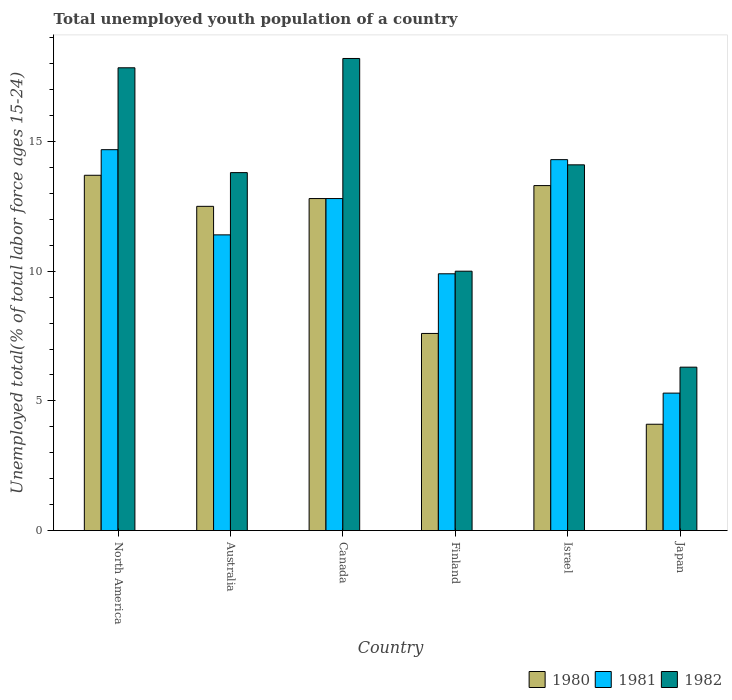How many groups of bars are there?
Provide a short and direct response. 6. Are the number of bars per tick equal to the number of legend labels?
Your answer should be very brief. Yes. Are the number of bars on each tick of the X-axis equal?
Ensure brevity in your answer.  Yes. How many bars are there on the 5th tick from the left?
Give a very brief answer. 3. How many bars are there on the 3rd tick from the right?
Provide a succinct answer. 3. What is the label of the 2nd group of bars from the left?
Provide a succinct answer. Australia. What is the percentage of total unemployed youth population of a country in 1982 in Finland?
Give a very brief answer. 10. Across all countries, what is the maximum percentage of total unemployed youth population of a country in 1980?
Ensure brevity in your answer.  13.7. Across all countries, what is the minimum percentage of total unemployed youth population of a country in 1982?
Provide a short and direct response. 6.3. What is the total percentage of total unemployed youth population of a country in 1981 in the graph?
Keep it short and to the point. 68.38. What is the difference between the percentage of total unemployed youth population of a country in 1982 in Australia and that in Japan?
Make the answer very short. 7.5. What is the difference between the percentage of total unemployed youth population of a country in 1980 in North America and the percentage of total unemployed youth population of a country in 1982 in Japan?
Your answer should be compact. 7.4. What is the average percentage of total unemployed youth population of a country in 1982 per country?
Offer a terse response. 13.37. What is the difference between the percentage of total unemployed youth population of a country of/in 1982 and percentage of total unemployed youth population of a country of/in 1981 in North America?
Keep it short and to the point. 3.16. What is the ratio of the percentage of total unemployed youth population of a country in 1982 in Canada to that in Japan?
Provide a succinct answer. 2.89. Is the percentage of total unemployed youth population of a country in 1981 in Japan less than that in North America?
Offer a terse response. Yes. Is the difference between the percentage of total unemployed youth population of a country in 1982 in Australia and Canada greater than the difference between the percentage of total unemployed youth population of a country in 1981 in Australia and Canada?
Offer a terse response. No. What is the difference between the highest and the second highest percentage of total unemployed youth population of a country in 1982?
Give a very brief answer. -0.36. What is the difference between the highest and the lowest percentage of total unemployed youth population of a country in 1980?
Ensure brevity in your answer.  9.6. In how many countries, is the percentage of total unemployed youth population of a country in 1982 greater than the average percentage of total unemployed youth population of a country in 1982 taken over all countries?
Provide a succinct answer. 4. Is the sum of the percentage of total unemployed youth population of a country in 1982 in Australia and North America greater than the maximum percentage of total unemployed youth population of a country in 1980 across all countries?
Your answer should be very brief. Yes. What does the 1st bar from the left in Australia represents?
Give a very brief answer. 1980. Is it the case that in every country, the sum of the percentage of total unemployed youth population of a country in 1982 and percentage of total unemployed youth population of a country in 1980 is greater than the percentage of total unemployed youth population of a country in 1981?
Your response must be concise. Yes. How many bars are there?
Provide a short and direct response. 18. Are all the bars in the graph horizontal?
Keep it short and to the point. No. How many countries are there in the graph?
Offer a terse response. 6. What is the difference between two consecutive major ticks on the Y-axis?
Provide a succinct answer. 5. Does the graph contain any zero values?
Your answer should be compact. No. How many legend labels are there?
Your answer should be very brief. 3. What is the title of the graph?
Your response must be concise. Total unemployed youth population of a country. Does "2010" appear as one of the legend labels in the graph?
Provide a succinct answer. No. What is the label or title of the Y-axis?
Offer a very short reply. Unemployed total(% of total labor force ages 15-24). What is the Unemployed total(% of total labor force ages 15-24) of 1980 in North America?
Ensure brevity in your answer.  13.7. What is the Unemployed total(% of total labor force ages 15-24) in 1981 in North America?
Provide a short and direct response. 14.68. What is the Unemployed total(% of total labor force ages 15-24) of 1982 in North America?
Make the answer very short. 17.84. What is the Unemployed total(% of total labor force ages 15-24) in 1981 in Australia?
Ensure brevity in your answer.  11.4. What is the Unemployed total(% of total labor force ages 15-24) in 1982 in Australia?
Keep it short and to the point. 13.8. What is the Unemployed total(% of total labor force ages 15-24) of 1980 in Canada?
Your answer should be very brief. 12.8. What is the Unemployed total(% of total labor force ages 15-24) of 1981 in Canada?
Your answer should be compact. 12.8. What is the Unemployed total(% of total labor force ages 15-24) in 1982 in Canada?
Provide a succinct answer. 18.2. What is the Unemployed total(% of total labor force ages 15-24) of 1980 in Finland?
Make the answer very short. 7.6. What is the Unemployed total(% of total labor force ages 15-24) of 1981 in Finland?
Offer a terse response. 9.9. What is the Unemployed total(% of total labor force ages 15-24) in 1982 in Finland?
Provide a short and direct response. 10. What is the Unemployed total(% of total labor force ages 15-24) of 1980 in Israel?
Make the answer very short. 13.3. What is the Unemployed total(% of total labor force ages 15-24) in 1981 in Israel?
Your answer should be very brief. 14.3. What is the Unemployed total(% of total labor force ages 15-24) of 1982 in Israel?
Offer a terse response. 14.1. What is the Unemployed total(% of total labor force ages 15-24) in 1980 in Japan?
Your response must be concise. 4.1. What is the Unemployed total(% of total labor force ages 15-24) in 1981 in Japan?
Offer a terse response. 5.3. What is the Unemployed total(% of total labor force ages 15-24) in 1982 in Japan?
Your response must be concise. 6.3. Across all countries, what is the maximum Unemployed total(% of total labor force ages 15-24) in 1980?
Ensure brevity in your answer.  13.7. Across all countries, what is the maximum Unemployed total(% of total labor force ages 15-24) in 1981?
Your answer should be very brief. 14.68. Across all countries, what is the maximum Unemployed total(% of total labor force ages 15-24) of 1982?
Ensure brevity in your answer.  18.2. Across all countries, what is the minimum Unemployed total(% of total labor force ages 15-24) in 1980?
Give a very brief answer. 4.1. Across all countries, what is the minimum Unemployed total(% of total labor force ages 15-24) of 1981?
Your response must be concise. 5.3. Across all countries, what is the minimum Unemployed total(% of total labor force ages 15-24) in 1982?
Provide a succinct answer. 6.3. What is the total Unemployed total(% of total labor force ages 15-24) of 1980 in the graph?
Give a very brief answer. 64. What is the total Unemployed total(% of total labor force ages 15-24) of 1981 in the graph?
Offer a very short reply. 68.38. What is the total Unemployed total(% of total labor force ages 15-24) in 1982 in the graph?
Your answer should be compact. 80.24. What is the difference between the Unemployed total(% of total labor force ages 15-24) in 1980 in North America and that in Australia?
Offer a terse response. 1.2. What is the difference between the Unemployed total(% of total labor force ages 15-24) of 1981 in North America and that in Australia?
Provide a short and direct response. 3.28. What is the difference between the Unemployed total(% of total labor force ages 15-24) in 1982 in North America and that in Australia?
Your answer should be compact. 4.04. What is the difference between the Unemployed total(% of total labor force ages 15-24) in 1980 in North America and that in Canada?
Offer a terse response. 0.9. What is the difference between the Unemployed total(% of total labor force ages 15-24) in 1981 in North America and that in Canada?
Offer a very short reply. 1.88. What is the difference between the Unemployed total(% of total labor force ages 15-24) of 1982 in North America and that in Canada?
Your answer should be compact. -0.36. What is the difference between the Unemployed total(% of total labor force ages 15-24) in 1980 in North America and that in Finland?
Keep it short and to the point. 6.1. What is the difference between the Unemployed total(% of total labor force ages 15-24) in 1981 in North America and that in Finland?
Your response must be concise. 4.78. What is the difference between the Unemployed total(% of total labor force ages 15-24) of 1982 in North America and that in Finland?
Offer a terse response. 7.84. What is the difference between the Unemployed total(% of total labor force ages 15-24) in 1980 in North America and that in Israel?
Your answer should be very brief. 0.4. What is the difference between the Unemployed total(% of total labor force ages 15-24) of 1981 in North America and that in Israel?
Provide a succinct answer. 0.38. What is the difference between the Unemployed total(% of total labor force ages 15-24) in 1982 in North America and that in Israel?
Provide a succinct answer. 3.74. What is the difference between the Unemployed total(% of total labor force ages 15-24) in 1980 in North America and that in Japan?
Make the answer very short. 9.6. What is the difference between the Unemployed total(% of total labor force ages 15-24) of 1981 in North America and that in Japan?
Keep it short and to the point. 9.38. What is the difference between the Unemployed total(% of total labor force ages 15-24) of 1982 in North America and that in Japan?
Make the answer very short. 11.54. What is the difference between the Unemployed total(% of total labor force ages 15-24) in 1980 in Australia and that in Canada?
Your answer should be compact. -0.3. What is the difference between the Unemployed total(% of total labor force ages 15-24) of 1981 in Australia and that in Canada?
Offer a terse response. -1.4. What is the difference between the Unemployed total(% of total labor force ages 15-24) of 1982 in Australia and that in Canada?
Provide a succinct answer. -4.4. What is the difference between the Unemployed total(% of total labor force ages 15-24) of 1981 in Australia and that in Finland?
Your answer should be very brief. 1.5. What is the difference between the Unemployed total(% of total labor force ages 15-24) of 1982 in Australia and that in Finland?
Your answer should be compact. 3.8. What is the difference between the Unemployed total(% of total labor force ages 15-24) of 1982 in Australia and that in Japan?
Your response must be concise. 7.5. What is the difference between the Unemployed total(% of total labor force ages 15-24) in 1980 in Canada and that in Israel?
Your response must be concise. -0.5. What is the difference between the Unemployed total(% of total labor force ages 15-24) in 1981 in Canada and that in Israel?
Keep it short and to the point. -1.5. What is the difference between the Unemployed total(% of total labor force ages 15-24) in 1982 in Canada and that in Japan?
Provide a short and direct response. 11.9. What is the difference between the Unemployed total(% of total labor force ages 15-24) in 1980 in Finland and that in Israel?
Make the answer very short. -5.7. What is the difference between the Unemployed total(% of total labor force ages 15-24) in 1981 in Finland and that in Israel?
Offer a very short reply. -4.4. What is the difference between the Unemployed total(% of total labor force ages 15-24) in 1980 in Finland and that in Japan?
Give a very brief answer. 3.5. What is the difference between the Unemployed total(% of total labor force ages 15-24) in 1981 in Finland and that in Japan?
Ensure brevity in your answer.  4.6. What is the difference between the Unemployed total(% of total labor force ages 15-24) in 1981 in Israel and that in Japan?
Ensure brevity in your answer.  9. What is the difference between the Unemployed total(% of total labor force ages 15-24) of 1982 in Israel and that in Japan?
Your response must be concise. 7.8. What is the difference between the Unemployed total(% of total labor force ages 15-24) of 1980 in North America and the Unemployed total(% of total labor force ages 15-24) of 1981 in Australia?
Ensure brevity in your answer.  2.3. What is the difference between the Unemployed total(% of total labor force ages 15-24) in 1980 in North America and the Unemployed total(% of total labor force ages 15-24) in 1982 in Australia?
Offer a terse response. -0.1. What is the difference between the Unemployed total(% of total labor force ages 15-24) in 1981 in North America and the Unemployed total(% of total labor force ages 15-24) in 1982 in Australia?
Ensure brevity in your answer.  0.88. What is the difference between the Unemployed total(% of total labor force ages 15-24) of 1980 in North America and the Unemployed total(% of total labor force ages 15-24) of 1981 in Canada?
Offer a very short reply. 0.9. What is the difference between the Unemployed total(% of total labor force ages 15-24) of 1980 in North America and the Unemployed total(% of total labor force ages 15-24) of 1982 in Canada?
Your response must be concise. -4.5. What is the difference between the Unemployed total(% of total labor force ages 15-24) in 1981 in North America and the Unemployed total(% of total labor force ages 15-24) in 1982 in Canada?
Make the answer very short. -3.52. What is the difference between the Unemployed total(% of total labor force ages 15-24) in 1980 in North America and the Unemployed total(% of total labor force ages 15-24) in 1981 in Finland?
Ensure brevity in your answer.  3.8. What is the difference between the Unemployed total(% of total labor force ages 15-24) in 1980 in North America and the Unemployed total(% of total labor force ages 15-24) in 1982 in Finland?
Your answer should be compact. 3.7. What is the difference between the Unemployed total(% of total labor force ages 15-24) in 1981 in North America and the Unemployed total(% of total labor force ages 15-24) in 1982 in Finland?
Provide a succinct answer. 4.68. What is the difference between the Unemployed total(% of total labor force ages 15-24) of 1980 in North America and the Unemployed total(% of total labor force ages 15-24) of 1981 in Israel?
Offer a terse response. -0.6. What is the difference between the Unemployed total(% of total labor force ages 15-24) of 1980 in North America and the Unemployed total(% of total labor force ages 15-24) of 1982 in Israel?
Ensure brevity in your answer.  -0.4. What is the difference between the Unemployed total(% of total labor force ages 15-24) in 1981 in North America and the Unemployed total(% of total labor force ages 15-24) in 1982 in Israel?
Ensure brevity in your answer.  0.58. What is the difference between the Unemployed total(% of total labor force ages 15-24) of 1980 in North America and the Unemployed total(% of total labor force ages 15-24) of 1981 in Japan?
Ensure brevity in your answer.  8.4. What is the difference between the Unemployed total(% of total labor force ages 15-24) in 1980 in North America and the Unemployed total(% of total labor force ages 15-24) in 1982 in Japan?
Make the answer very short. 7.4. What is the difference between the Unemployed total(% of total labor force ages 15-24) of 1981 in North America and the Unemployed total(% of total labor force ages 15-24) of 1982 in Japan?
Ensure brevity in your answer.  8.38. What is the difference between the Unemployed total(% of total labor force ages 15-24) in 1980 in Australia and the Unemployed total(% of total labor force ages 15-24) in 1981 in Canada?
Your answer should be compact. -0.3. What is the difference between the Unemployed total(% of total labor force ages 15-24) of 1980 in Australia and the Unemployed total(% of total labor force ages 15-24) of 1981 in Finland?
Provide a short and direct response. 2.6. What is the difference between the Unemployed total(% of total labor force ages 15-24) in 1980 in Australia and the Unemployed total(% of total labor force ages 15-24) in 1981 in Israel?
Make the answer very short. -1.8. What is the difference between the Unemployed total(% of total labor force ages 15-24) of 1980 in Australia and the Unemployed total(% of total labor force ages 15-24) of 1981 in Japan?
Keep it short and to the point. 7.2. What is the difference between the Unemployed total(% of total labor force ages 15-24) of 1980 in Australia and the Unemployed total(% of total labor force ages 15-24) of 1982 in Japan?
Offer a terse response. 6.2. What is the difference between the Unemployed total(% of total labor force ages 15-24) in 1980 in Canada and the Unemployed total(% of total labor force ages 15-24) in 1981 in Finland?
Ensure brevity in your answer.  2.9. What is the difference between the Unemployed total(% of total labor force ages 15-24) of 1981 in Canada and the Unemployed total(% of total labor force ages 15-24) of 1982 in Finland?
Offer a terse response. 2.8. What is the difference between the Unemployed total(% of total labor force ages 15-24) of 1980 in Canada and the Unemployed total(% of total labor force ages 15-24) of 1981 in Israel?
Keep it short and to the point. -1.5. What is the difference between the Unemployed total(% of total labor force ages 15-24) in 1980 in Canada and the Unemployed total(% of total labor force ages 15-24) in 1982 in Israel?
Provide a succinct answer. -1.3. What is the difference between the Unemployed total(% of total labor force ages 15-24) in 1980 in Canada and the Unemployed total(% of total labor force ages 15-24) in 1981 in Japan?
Your response must be concise. 7.5. What is the difference between the Unemployed total(% of total labor force ages 15-24) of 1981 in Canada and the Unemployed total(% of total labor force ages 15-24) of 1982 in Japan?
Keep it short and to the point. 6.5. What is the difference between the Unemployed total(% of total labor force ages 15-24) of 1980 in Finland and the Unemployed total(% of total labor force ages 15-24) of 1981 in Israel?
Provide a short and direct response. -6.7. What is the difference between the Unemployed total(% of total labor force ages 15-24) in 1980 in Finland and the Unemployed total(% of total labor force ages 15-24) in 1982 in Israel?
Offer a very short reply. -6.5. What is the difference between the Unemployed total(% of total labor force ages 15-24) in 1981 in Finland and the Unemployed total(% of total labor force ages 15-24) in 1982 in Israel?
Make the answer very short. -4.2. What is the difference between the Unemployed total(% of total labor force ages 15-24) of 1980 in Finland and the Unemployed total(% of total labor force ages 15-24) of 1981 in Japan?
Your answer should be very brief. 2.3. What is the difference between the Unemployed total(% of total labor force ages 15-24) of 1980 in Finland and the Unemployed total(% of total labor force ages 15-24) of 1982 in Japan?
Offer a terse response. 1.3. What is the difference between the Unemployed total(% of total labor force ages 15-24) in 1980 in Israel and the Unemployed total(% of total labor force ages 15-24) in 1982 in Japan?
Your answer should be compact. 7. What is the average Unemployed total(% of total labor force ages 15-24) of 1980 per country?
Make the answer very short. 10.67. What is the average Unemployed total(% of total labor force ages 15-24) in 1981 per country?
Make the answer very short. 11.4. What is the average Unemployed total(% of total labor force ages 15-24) of 1982 per country?
Make the answer very short. 13.37. What is the difference between the Unemployed total(% of total labor force ages 15-24) in 1980 and Unemployed total(% of total labor force ages 15-24) in 1981 in North America?
Keep it short and to the point. -0.99. What is the difference between the Unemployed total(% of total labor force ages 15-24) of 1980 and Unemployed total(% of total labor force ages 15-24) of 1982 in North America?
Give a very brief answer. -4.14. What is the difference between the Unemployed total(% of total labor force ages 15-24) in 1981 and Unemployed total(% of total labor force ages 15-24) in 1982 in North America?
Keep it short and to the point. -3.16. What is the difference between the Unemployed total(% of total labor force ages 15-24) of 1981 and Unemployed total(% of total labor force ages 15-24) of 1982 in Australia?
Ensure brevity in your answer.  -2.4. What is the difference between the Unemployed total(% of total labor force ages 15-24) in 1980 and Unemployed total(% of total labor force ages 15-24) in 1981 in Canada?
Your response must be concise. 0. What is the difference between the Unemployed total(% of total labor force ages 15-24) of 1981 and Unemployed total(% of total labor force ages 15-24) of 1982 in Finland?
Ensure brevity in your answer.  -0.1. What is the difference between the Unemployed total(% of total labor force ages 15-24) of 1980 and Unemployed total(% of total labor force ages 15-24) of 1981 in Israel?
Give a very brief answer. -1. What is the difference between the Unemployed total(% of total labor force ages 15-24) in 1980 and Unemployed total(% of total labor force ages 15-24) in 1982 in Israel?
Your answer should be very brief. -0.8. What is the difference between the Unemployed total(% of total labor force ages 15-24) in 1981 and Unemployed total(% of total labor force ages 15-24) in 1982 in Israel?
Make the answer very short. 0.2. What is the difference between the Unemployed total(% of total labor force ages 15-24) of 1980 and Unemployed total(% of total labor force ages 15-24) of 1982 in Japan?
Your answer should be compact. -2.2. What is the ratio of the Unemployed total(% of total labor force ages 15-24) in 1980 in North America to that in Australia?
Keep it short and to the point. 1.1. What is the ratio of the Unemployed total(% of total labor force ages 15-24) in 1981 in North America to that in Australia?
Offer a very short reply. 1.29. What is the ratio of the Unemployed total(% of total labor force ages 15-24) in 1982 in North America to that in Australia?
Provide a short and direct response. 1.29. What is the ratio of the Unemployed total(% of total labor force ages 15-24) of 1980 in North America to that in Canada?
Keep it short and to the point. 1.07. What is the ratio of the Unemployed total(% of total labor force ages 15-24) of 1981 in North America to that in Canada?
Make the answer very short. 1.15. What is the ratio of the Unemployed total(% of total labor force ages 15-24) in 1982 in North America to that in Canada?
Your response must be concise. 0.98. What is the ratio of the Unemployed total(% of total labor force ages 15-24) of 1980 in North America to that in Finland?
Your answer should be very brief. 1.8. What is the ratio of the Unemployed total(% of total labor force ages 15-24) in 1981 in North America to that in Finland?
Your answer should be compact. 1.48. What is the ratio of the Unemployed total(% of total labor force ages 15-24) of 1982 in North America to that in Finland?
Provide a short and direct response. 1.78. What is the ratio of the Unemployed total(% of total labor force ages 15-24) in 1980 in North America to that in Israel?
Make the answer very short. 1.03. What is the ratio of the Unemployed total(% of total labor force ages 15-24) in 1981 in North America to that in Israel?
Your answer should be very brief. 1.03. What is the ratio of the Unemployed total(% of total labor force ages 15-24) of 1982 in North America to that in Israel?
Give a very brief answer. 1.27. What is the ratio of the Unemployed total(% of total labor force ages 15-24) in 1980 in North America to that in Japan?
Your answer should be compact. 3.34. What is the ratio of the Unemployed total(% of total labor force ages 15-24) of 1981 in North America to that in Japan?
Your answer should be compact. 2.77. What is the ratio of the Unemployed total(% of total labor force ages 15-24) of 1982 in North America to that in Japan?
Provide a succinct answer. 2.83. What is the ratio of the Unemployed total(% of total labor force ages 15-24) of 1980 in Australia to that in Canada?
Offer a very short reply. 0.98. What is the ratio of the Unemployed total(% of total labor force ages 15-24) in 1981 in Australia to that in Canada?
Ensure brevity in your answer.  0.89. What is the ratio of the Unemployed total(% of total labor force ages 15-24) of 1982 in Australia to that in Canada?
Provide a short and direct response. 0.76. What is the ratio of the Unemployed total(% of total labor force ages 15-24) in 1980 in Australia to that in Finland?
Offer a terse response. 1.64. What is the ratio of the Unemployed total(% of total labor force ages 15-24) in 1981 in Australia to that in Finland?
Give a very brief answer. 1.15. What is the ratio of the Unemployed total(% of total labor force ages 15-24) in 1982 in Australia to that in Finland?
Offer a very short reply. 1.38. What is the ratio of the Unemployed total(% of total labor force ages 15-24) in 1980 in Australia to that in Israel?
Your answer should be compact. 0.94. What is the ratio of the Unemployed total(% of total labor force ages 15-24) in 1981 in Australia to that in Israel?
Provide a succinct answer. 0.8. What is the ratio of the Unemployed total(% of total labor force ages 15-24) of 1982 in Australia to that in Israel?
Make the answer very short. 0.98. What is the ratio of the Unemployed total(% of total labor force ages 15-24) in 1980 in Australia to that in Japan?
Your response must be concise. 3.05. What is the ratio of the Unemployed total(% of total labor force ages 15-24) of 1981 in Australia to that in Japan?
Your answer should be very brief. 2.15. What is the ratio of the Unemployed total(% of total labor force ages 15-24) of 1982 in Australia to that in Japan?
Your response must be concise. 2.19. What is the ratio of the Unemployed total(% of total labor force ages 15-24) in 1980 in Canada to that in Finland?
Your answer should be very brief. 1.68. What is the ratio of the Unemployed total(% of total labor force ages 15-24) in 1981 in Canada to that in Finland?
Give a very brief answer. 1.29. What is the ratio of the Unemployed total(% of total labor force ages 15-24) of 1982 in Canada to that in Finland?
Keep it short and to the point. 1.82. What is the ratio of the Unemployed total(% of total labor force ages 15-24) in 1980 in Canada to that in Israel?
Provide a short and direct response. 0.96. What is the ratio of the Unemployed total(% of total labor force ages 15-24) in 1981 in Canada to that in Israel?
Your response must be concise. 0.9. What is the ratio of the Unemployed total(% of total labor force ages 15-24) in 1982 in Canada to that in Israel?
Provide a short and direct response. 1.29. What is the ratio of the Unemployed total(% of total labor force ages 15-24) of 1980 in Canada to that in Japan?
Keep it short and to the point. 3.12. What is the ratio of the Unemployed total(% of total labor force ages 15-24) in 1981 in Canada to that in Japan?
Your answer should be compact. 2.42. What is the ratio of the Unemployed total(% of total labor force ages 15-24) of 1982 in Canada to that in Japan?
Give a very brief answer. 2.89. What is the ratio of the Unemployed total(% of total labor force ages 15-24) in 1981 in Finland to that in Israel?
Provide a short and direct response. 0.69. What is the ratio of the Unemployed total(% of total labor force ages 15-24) of 1982 in Finland to that in Israel?
Provide a short and direct response. 0.71. What is the ratio of the Unemployed total(% of total labor force ages 15-24) in 1980 in Finland to that in Japan?
Your answer should be very brief. 1.85. What is the ratio of the Unemployed total(% of total labor force ages 15-24) in 1981 in Finland to that in Japan?
Offer a terse response. 1.87. What is the ratio of the Unemployed total(% of total labor force ages 15-24) of 1982 in Finland to that in Japan?
Ensure brevity in your answer.  1.59. What is the ratio of the Unemployed total(% of total labor force ages 15-24) in 1980 in Israel to that in Japan?
Ensure brevity in your answer.  3.24. What is the ratio of the Unemployed total(% of total labor force ages 15-24) in 1981 in Israel to that in Japan?
Your answer should be compact. 2.7. What is the ratio of the Unemployed total(% of total labor force ages 15-24) of 1982 in Israel to that in Japan?
Provide a succinct answer. 2.24. What is the difference between the highest and the second highest Unemployed total(% of total labor force ages 15-24) of 1980?
Give a very brief answer. 0.4. What is the difference between the highest and the second highest Unemployed total(% of total labor force ages 15-24) in 1981?
Offer a terse response. 0.38. What is the difference between the highest and the second highest Unemployed total(% of total labor force ages 15-24) in 1982?
Offer a very short reply. 0.36. What is the difference between the highest and the lowest Unemployed total(% of total labor force ages 15-24) in 1980?
Your answer should be very brief. 9.6. What is the difference between the highest and the lowest Unemployed total(% of total labor force ages 15-24) of 1981?
Give a very brief answer. 9.38. What is the difference between the highest and the lowest Unemployed total(% of total labor force ages 15-24) in 1982?
Your response must be concise. 11.9. 